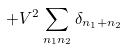<formula> <loc_0><loc_0><loc_500><loc_500>+ V ^ { 2 } \sum _ { n _ { 1 } n _ { 2 } } \delta _ { n _ { 1 } + n _ { 2 } }</formula> 